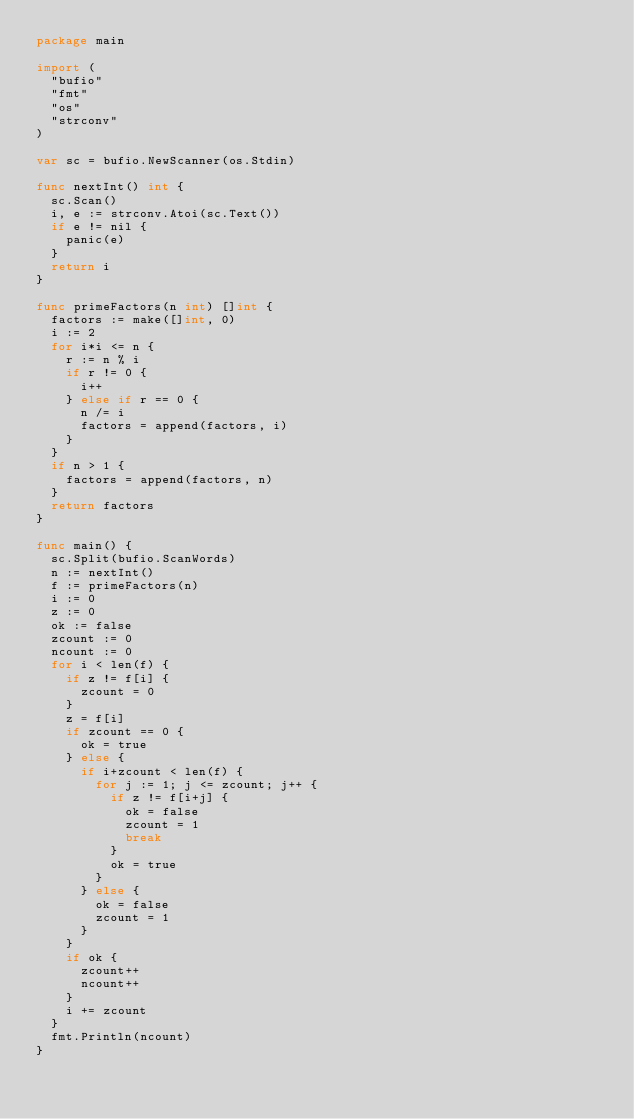Convert code to text. <code><loc_0><loc_0><loc_500><loc_500><_Go_>package main

import (
	"bufio"
	"fmt"
	"os"
	"strconv"
)

var sc = bufio.NewScanner(os.Stdin)

func nextInt() int {
	sc.Scan()
	i, e := strconv.Atoi(sc.Text())
	if e != nil {
		panic(e)
	}
	return i
}

func primeFactors(n int) []int {
	factors := make([]int, 0)
	i := 2
	for i*i <= n {
		r := n % i
		if r != 0 {
			i++
		} else if r == 0 {
			n /= i
			factors = append(factors, i)
		}
	}
	if n > 1 {
		factors = append(factors, n)
	}
	return factors
}

func main() {
	sc.Split(bufio.ScanWords)
	n := nextInt()
	f := primeFactors(n)
	i := 0
	z := 0
	ok := false
	zcount := 0
	ncount := 0
	for i < len(f) {
		if z != f[i] {
			zcount = 0
		}
		z = f[i]
		if zcount == 0 {
			ok = true
		} else {
			if i+zcount < len(f) {
				for j := 1; j <= zcount; j++ {
					if z != f[i+j] {
						ok = false
						zcount = 1
						break
					}
					ok = true
				}
			} else {
				ok = false
				zcount = 1
			}
		}
		if ok {
			zcount++
			ncount++
		}
		i += zcount
	}
	fmt.Println(ncount)
}
</code> 